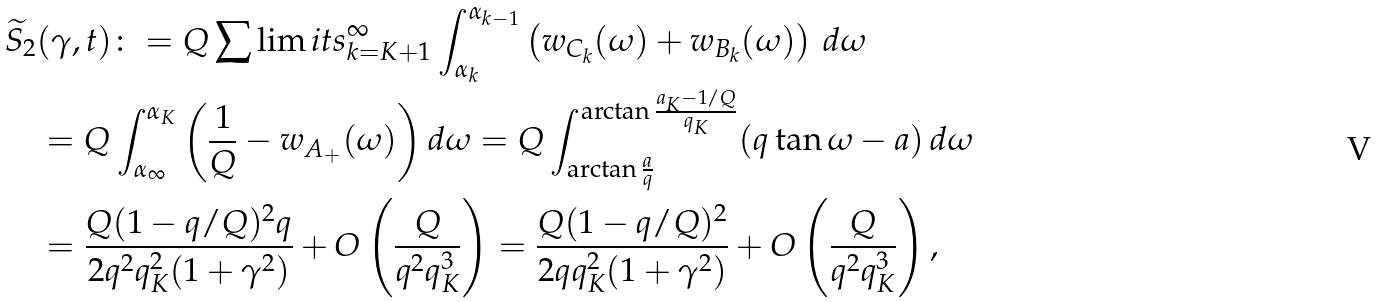Convert formula to latex. <formula><loc_0><loc_0><loc_500><loc_500>& \widetilde { S } _ { 2 } ( \gamma , t ) \colon = Q \sum \lim i t s _ { k = K + 1 } ^ { \infty } \int _ { \alpha _ { k } } ^ { \alpha _ { k - 1 } } \left ( w _ { C _ { k } } ( \omega ) + w _ { B _ { k } } ( \omega ) \right ) \, d \omega \\ & \quad = Q \int _ { \alpha _ { \infty } } ^ { \alpha _ { K } } \left ( \frac { 1 } { Q } - w _ { A _ { + } } ( \omega ) \right ) d \omega = Q \int _ { \arctan \frac { a } { q } } ^ { \arctan \frac { a _ { K } - 1 / Q } { q _ { K } } } ( q \tan \omega - a ) \, d \omega \\ & \quad = \frac { Q ( 1 - q / Q ) ^ { 2 } q } { 2 q ^ { 2 } q _ { K } ^ { 2 } ( 1 + \gamma ^ { 2 } ) } + O \left ( \frac { Q } { q ^ { 2 } q _ { K } ^ { 3 } } \right ) = \frac { Q ( 1 - q / Q ) ^ { 2 } } { 2 q q _ { K } ^ { 2 } ( 1 + \gamma ^ { 2 } ) } + O \left ( \frac { Q } { q ^ { 2 } q _ { K } ^ { 3 } } \right ) ,</formula> 